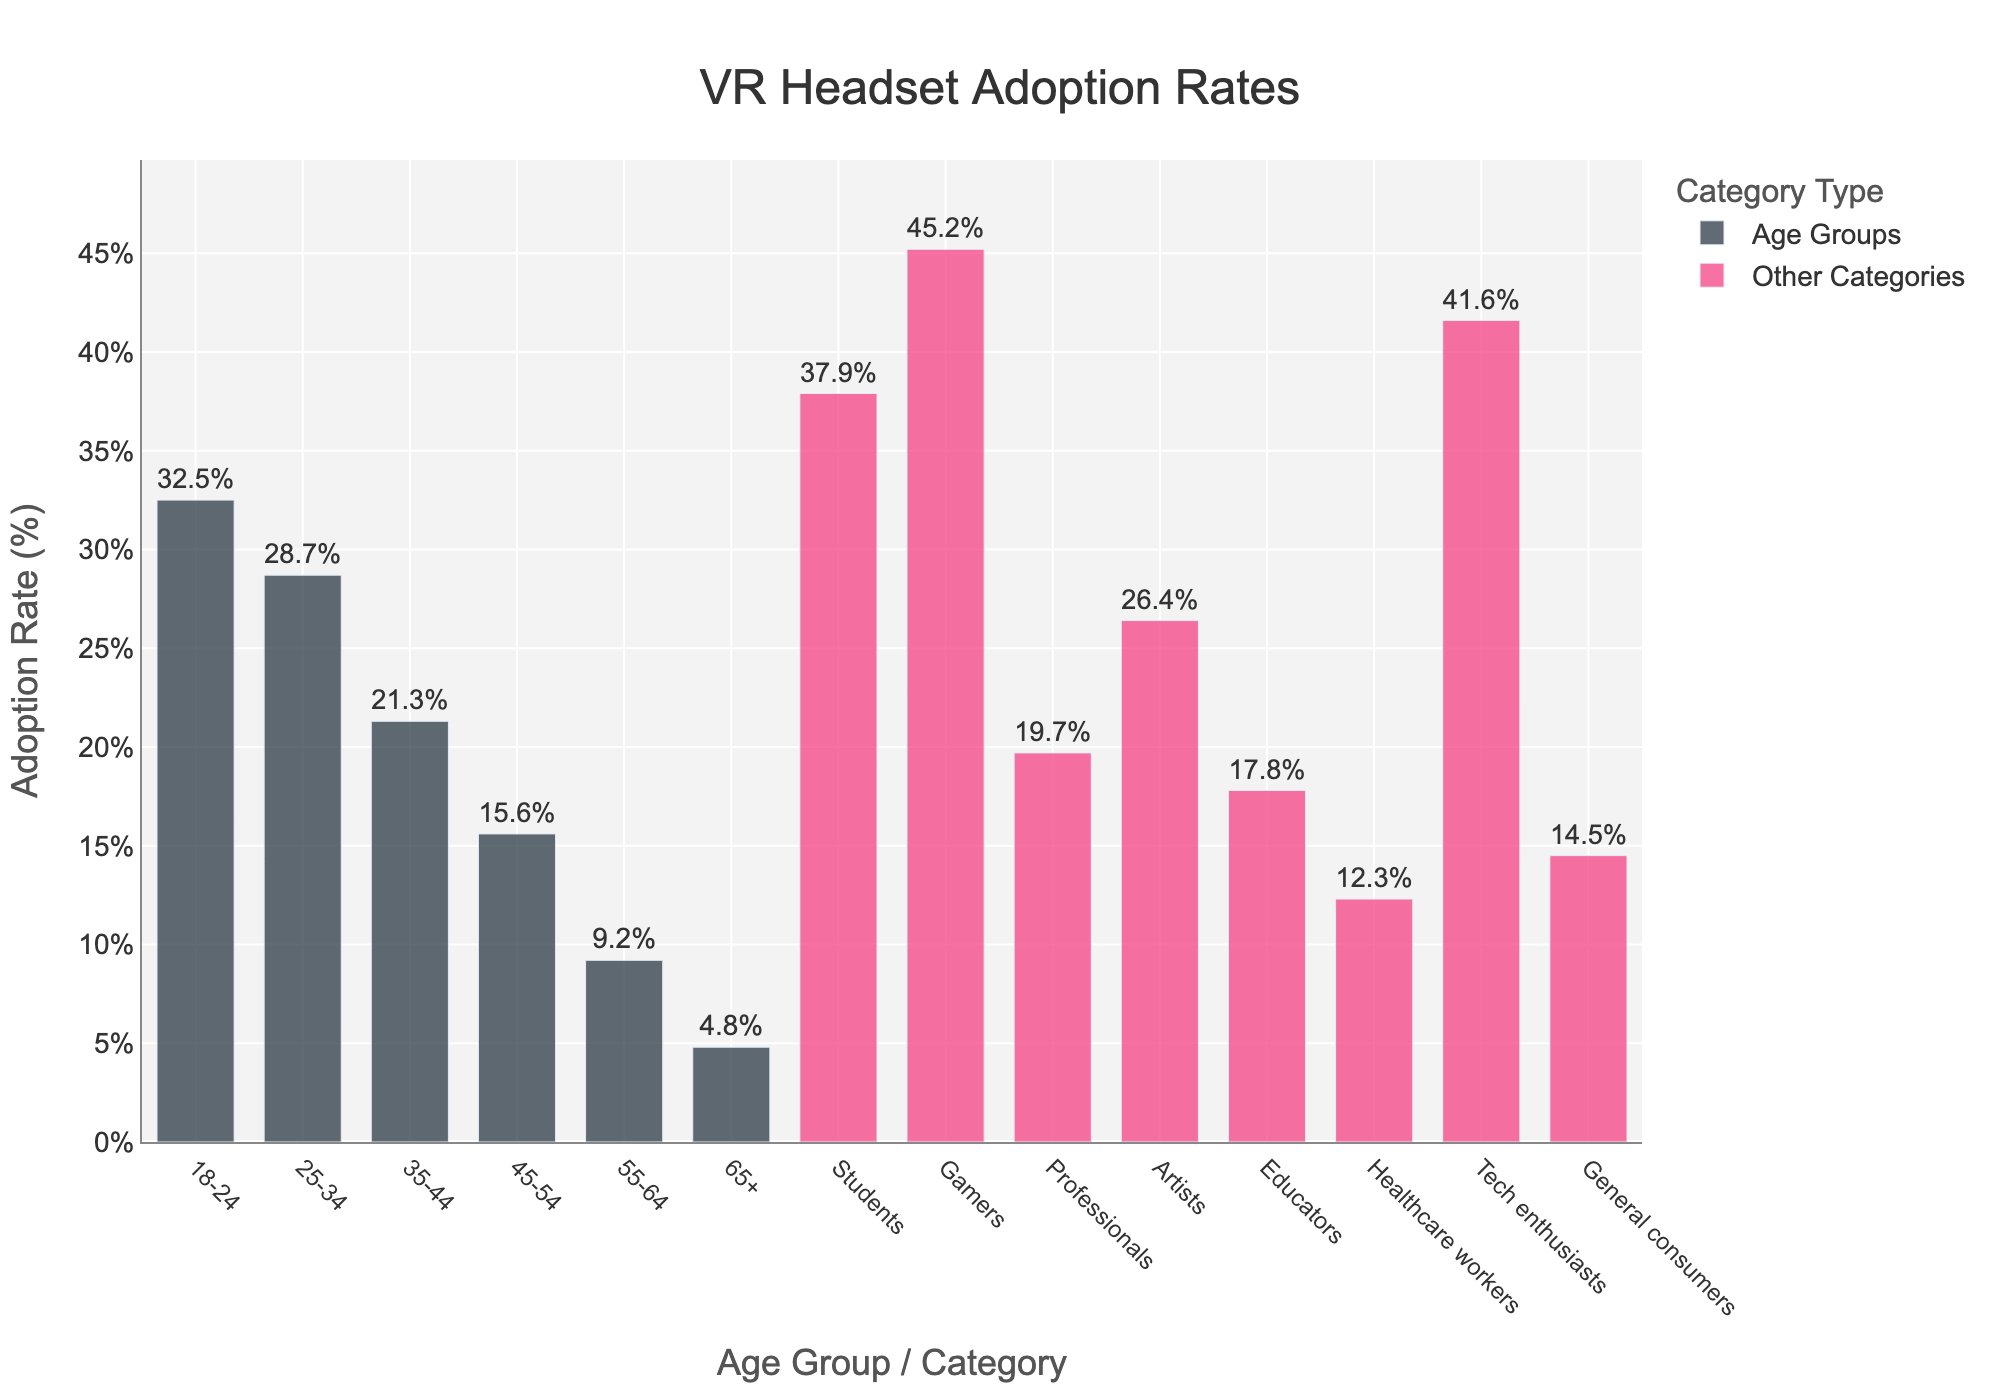What age group has the highest VR headset adoption rate? The bars for age groups show the adoption rates, and the tallest bar represents the 18-24 age group with a 32.5% adoption rate.
Answer: 18-24 How much lower is the adoption rate for age group 35-44 compared to 25-34? The adoption rate for 35-44 is 21.3%, and for 25-34, it is 28.7%. Subtracting 21.3% from 28.7% gives 7.4%.
Answer: 7.4% Which non-age category has the highest adoption rate for VR headsets? The tallest bar among non-age categories represents Gamers with a 45.2% adoption rate.
Answer: Gamers What's the total adoption rate for the age groups 45-54, 55-64, and 65+? Summing up the adoption rates: 15.6% (45-54) + 9.2% (55-64) + 4.8% (65+) equals 29.6%.
Answer: 29.6% Is the adoption rate for Educators higher than that for Healthcare workers? The bar for Educators shows 17.8%, and for Healthcare workers, it shows 12.3%. 17.8% is greater than 12.3%.
Answer: Yes Which has a lower adoption rate, Professionals or General consumers? The bar for Professionals shows 19.7%, and for General consumers, it is 14.5%. Comparing these, 14.5% is lower than 19.7%.
Answer: General consumers What is the height difference between the adoption rates of Tech enthusiasts and Artists? The adoption rate for Tech enthusiasts is 41.6%, and for Artists, it's 26.4%. The difference is 41.6% - 26.4%, which equals 15.2%.
Answer: 15.2% Which group has a higher adoption rate, Students or Tech enthusiasts? Comparing the bars, Students have a 37.9% rate, and Tech enthusiasts have 41.6%. 41.6% is greater than 37.9%.
Answer: Tech enthusiasts What's the combined adoption rate for age groups below 45 years (18-24, 25-34, and 35-44)? Adding the rates: 32.5% (18-24) + 28.7% (25-34) + 21.3% (35-44) gives 82.5%.
Answer: 82.5% 